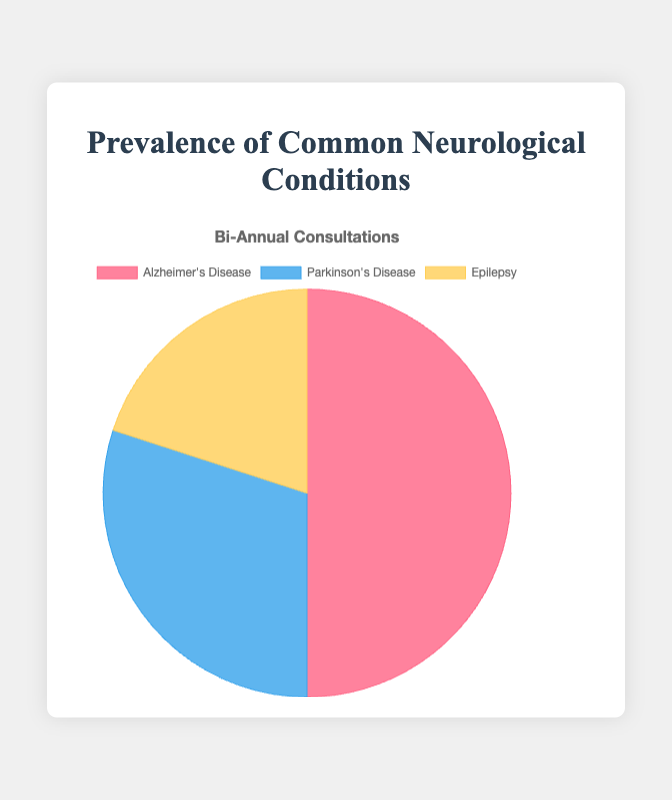What percentage of the bi-annual consultations are for Alzheimer's Disease? The data shows that there are 500 consultations for Alzheimer's Disease out of a total of 1000 consultations (500 for Alzheimer's, 300 for Parkinson's, and 200 for Epilepsy). The percentage is calculated as (500 / 1000) * 100.
Answer: 50% How do the bi-annual consultations for Parkinson's Disease compare to those for Epilepsy? Parkinson's Disease has 300 consultations, whereas Epilepsy has 200 consultations. To compare, we see that Parkinson's Disease has 100 more consultations than Epilepsy.
Answer: Parkinson's Disease has 100 more consultations Which neurological condition has the least number of bi-annual consultations? The chart shows Alzheimer's Disease with 500 consultations, Parkinson's Disease with 300 consultations, and Epilepsy with 200 consultations. Epilepsy has the least number of consultations.
Answer: Epilepsy What is the combined total of bi-annual consultations for Parkinson's Disease and Epilepsy? Parkinson's Disease has 300 consultations and Epilepsy has 200 consultations. The combined total is 300 + 200.
Answer: 500 What is the difference in the number of bi-annual consultations between Alzheimer's Disease and the other two conditions combined? Alzheimer's Disease has 500 consultations. Parkinson's Disease and Epilepsy together have 300 + 200 = 500 consultations. The difference is 500 - 500.
Answer: 0 Based on the pie chart colors, which condition is represented by the blue section? The pie chart shows Parkinson's Disease in blue.
Answer: Parkinson's Disease If you combine the bi-annual consultations for Parkinson's Disease and Alzheimer's Disease, what percentage of the total does it represent? Parkinson's Disease has 300 consultations, and Alzheimer's Disease has 500 consultations, making a combined total of 800. The total consultations are 1000. The percentage is (800 / 1000) * 100.
Answer: 80% Which condition shows the second-highest number of bi-annual consultations? The chart shows Alzheimer's Disease with 500, Parkinson's Disease with 300, and Epilepsy with 200 consultations. Parkinson's Disease is the second highest.
Answer: Parkinson's Disease What fraction of the consultations are for Epilepsy compared to the total? Epilepsy has 200 consultations. The total is 1000. The fraction is 200 / 1000.
Answer: 1/5 